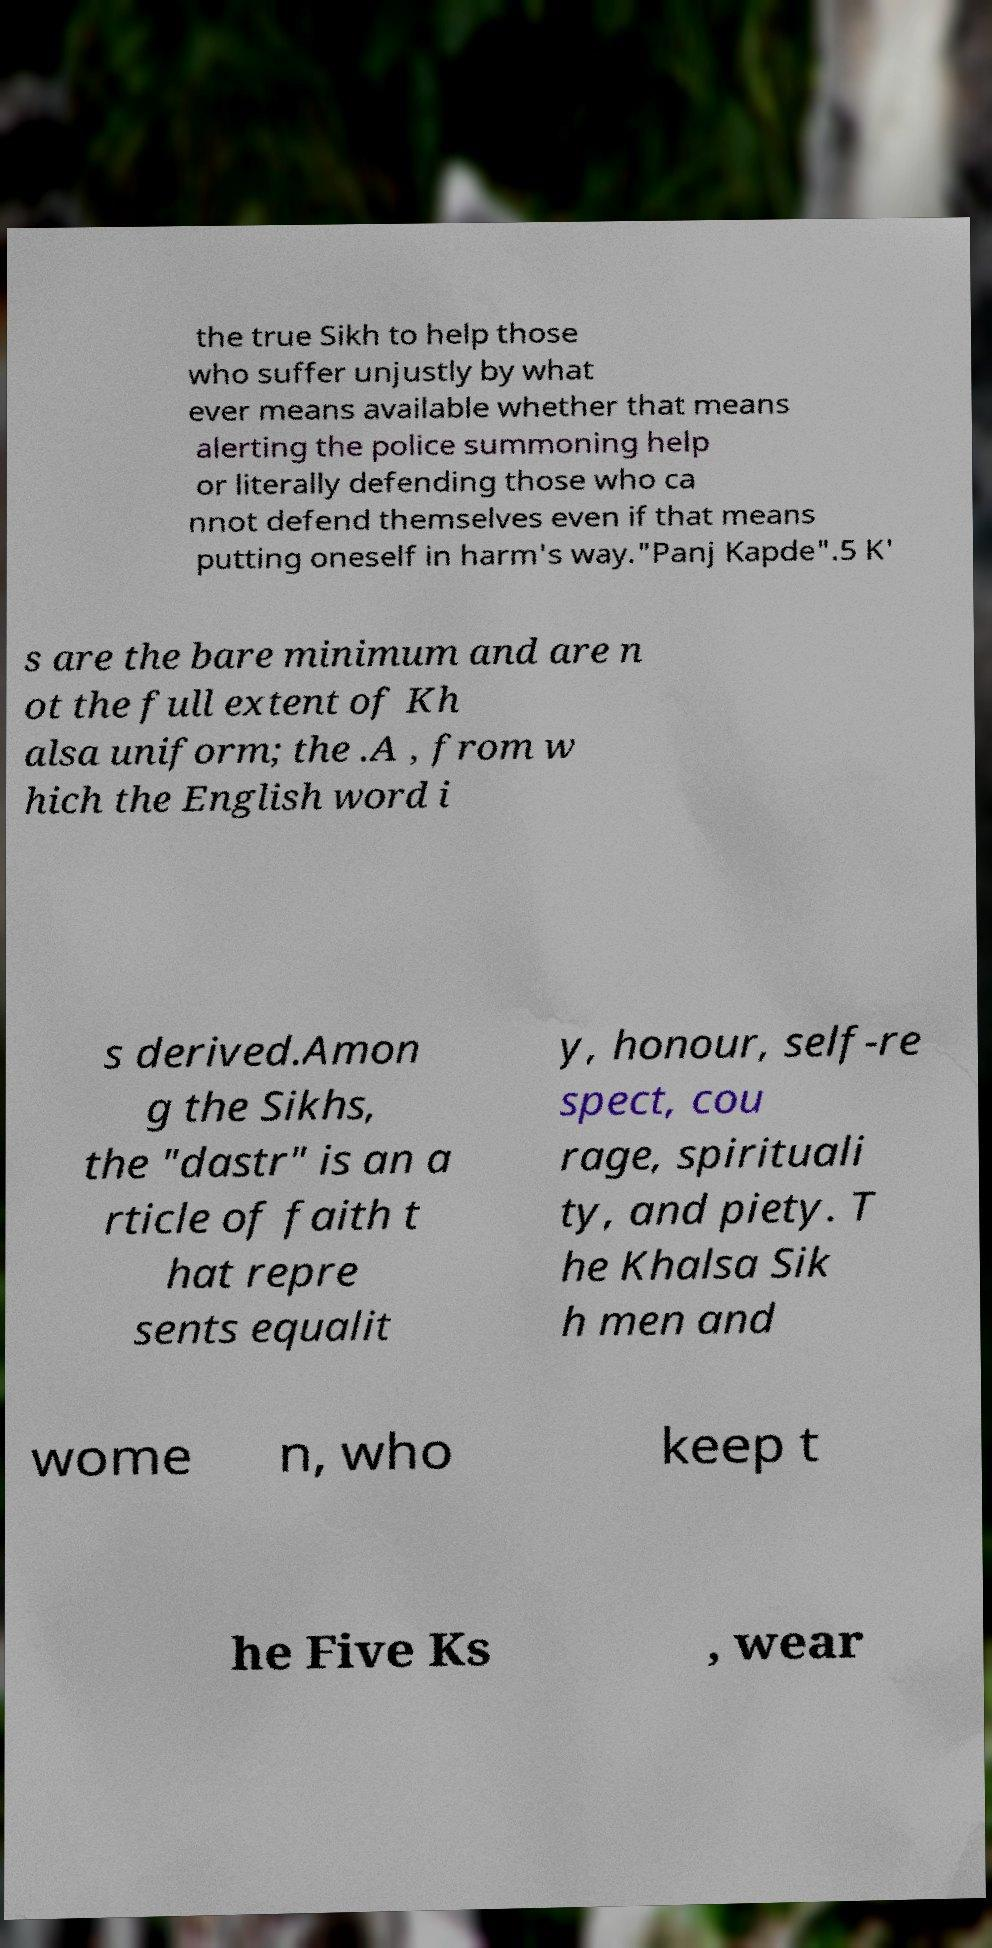Could you extract and type out the text from this image? the true Sikh to help those who suffer unjustly by what ever means available whether that means alerting the police summoning help or literally defending those who ca nnot defend themselves even if that means putting oneself in harm's way."Panj Kapde".5 K' s are the bare minimum and are n ot the full extent of Kh alsa uniform; the .A , from w hich the English word i s derived.Amon g the Sikhs, the "dastr" is an a rticle of faith t hat repre sents equalit y, honour, self-re spect, cou rage, spirituali ty, and piety. T he Khalsa Sik h men and wome n, who keep t he Five Ks , wear 